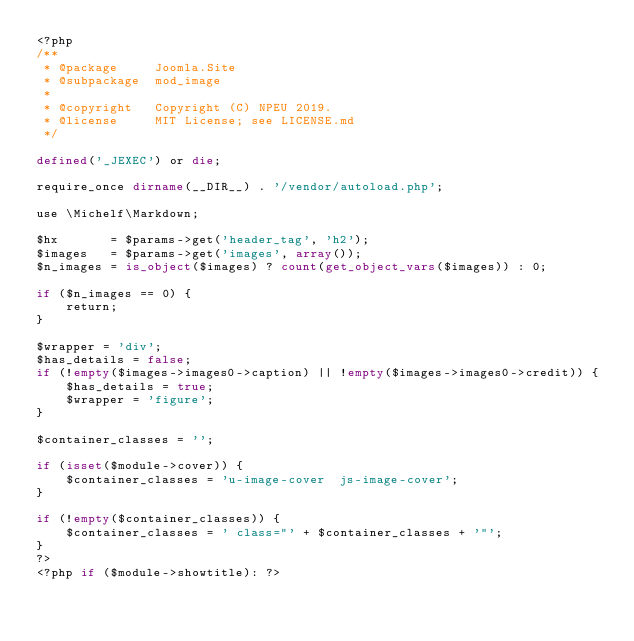<code> <loc_0><loc_0><loc_500><loc_500><_PHP_><?php
/**
 * @package     Joomla.Site
 * @subpackage  mod_image
 *
 * @copyright   Copyright (C) NPEU 2019.
 * @license     MIT License; see LICENSE.md
 */

defined('_JEXEC') or die;

require_once dirname(__DIR__) . '/vendor/autoload.php';

use \Michelf\Markdown;

$hx       = $params->get('header_tag', 'h2');
$images   = $params->get('images', array());
$n_images = is_object($images) ? count(get_object_vars($images)) : 0;

if ($n_images == 0) {
    return;
}

$wrapper = 'div';
$has_details = false;
if (!empty($images->images0->caption) || !empty($images->images0->credit)) {
    $has_details = true;
    $wrapper = 'figure';
}

$container_classes = '';

if (isset($module->cover)) {
    $container_classes = 'u-image-cover  js-image-cover';
}

if (!empty($container_classes)) {
    $container_classes = ' class="' + $container_classes + '"';
}
?>
<?php if ($module->showtitle): ?></code> 